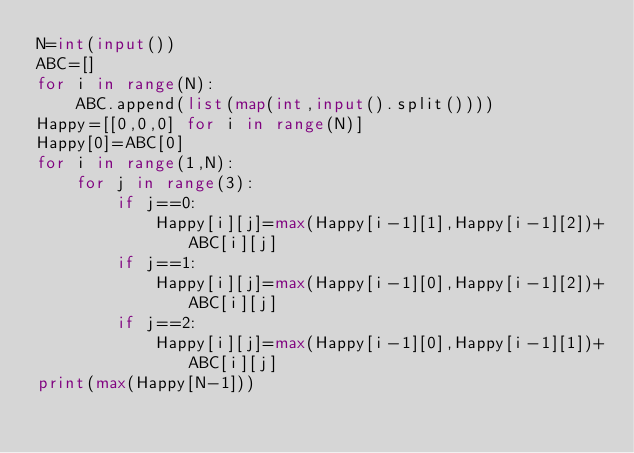Convert code to text. <code><loc_0><loc_0><loc_500><loc_500><_Python_>N=int(input())
ABC=[]
for i in range(N):
    ABC.append(list(map(int,input().split())))
Happy=[[0,0,0] for i in range(N)]
Happy[0]=ABC[0]
for i in range(1,N):
    for j in range(3):
        if j==0:
            Happy[i][j]=max(Happy[i-1][1],Happy[i-1][2])+ABC[i][j]
        if j==1:
            Happy[i][j]=max(Happy[i-1][0],Happy[i-1][2])+ABC[i][j]
        if j==2:
            Happy[i][j]=max(Happy[i-1][0],Happy[i-1][1])+ABC[i][j]
print(max(Happy[N-1]))</code> 